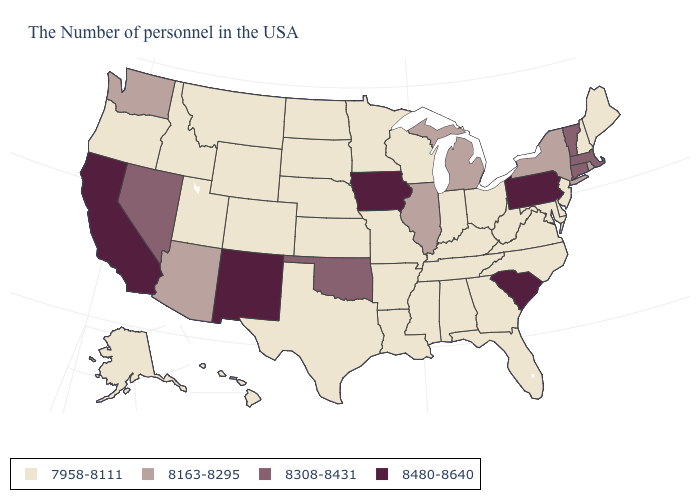Name the states that have a value in the range 8480-8640?
Short answer required. Pennsylvania, South Carolina, Iowa, New Mexico, California. How many symbols are there in the legend?
Answer briefly. 4. What is the value of North Carolina?
Give a very brief answer. 7958-8111. Among the states that border Virginia , which have the highest value?
Be succinct. Maryland, North Carolina, West Virginia, Kentucky, Tennessee. Name the states that have a value in the range 8163-8295?
Keep it brief. Rhode Island, New York, Michigan, Illinois, Arizona, Washington. Is the legend a continuous bar?
Short answer required. No. What is the value of New Mexico?
Concise answer only. 8480-8640. Does the first symbol in the legend represent the smallest category?
Short answer required. Yes. What is the lowest value in states that border Louisiana?
Concise answer only. 7958-8111. How many symbols are there in the legend?
Concise answer only. 4. Does South Carolina have the highest value in the South?
Write a very short answer. Yes. Among the states that border Idaho , which have the highest value?
Quick response, please. Nevada. What is the lowest value in the MidWest?
Answer briefly. 7958-8111. Does the map have missing data?
Be succinct. No. What is the value of South Carolina?
Give a very brief answer. 8480-8640. 